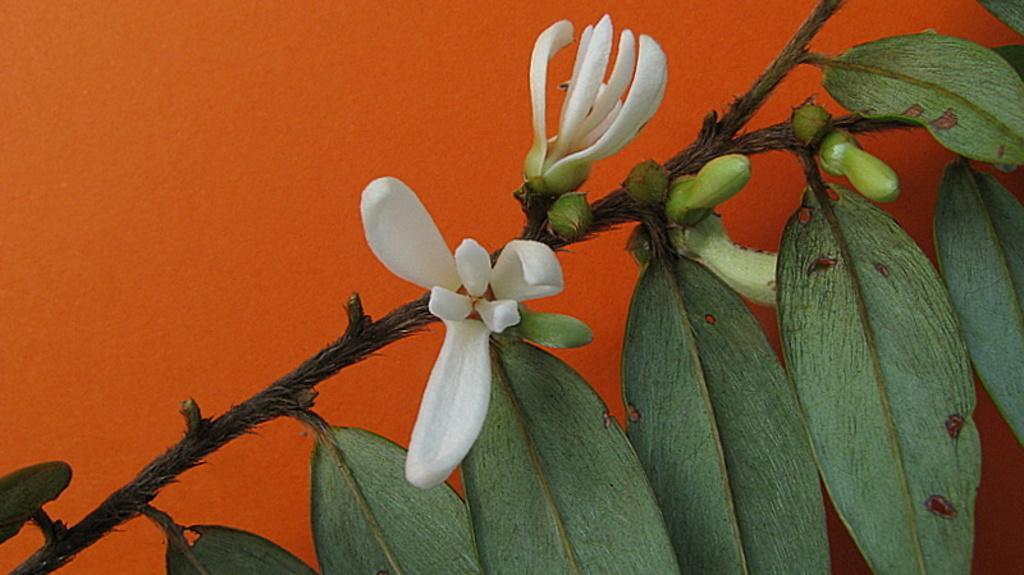Could you give a brief overview of what you see in this image? In the foreground of this image, there are flowers and buds to a plant and there is an orange background. 